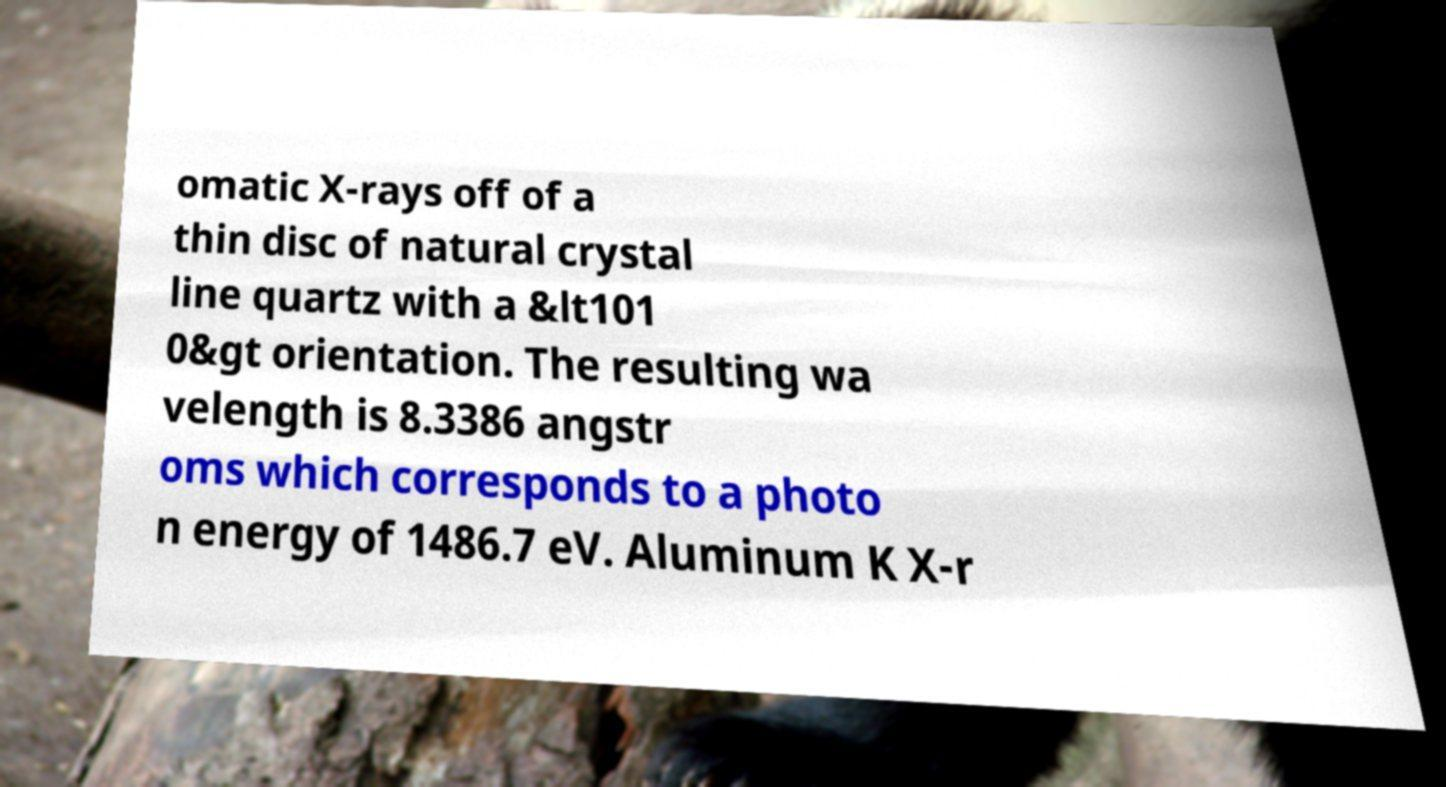For documentation purposes, I need the text within this image transcribed. Could you provide that? omatic X-rays off of a thin disc of natural crystal line quartz with a &lt101 0&gt orientation. The resulting wa velength is 8.3386 angstr oms which corresponds to a photo n energy of 1486.7 eV. Aluminum K X-r 